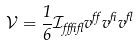Convert formula to latex. <formula><loc_0><loc_0><loc_500><loc_500>\mathcal { V } = \frac { 1 } { 6 } \mathcal { I } _ { \alpha \beta \gamma } v ^ { \alpha } v ^ { \beta } v ^ { \gamma }</formula> 